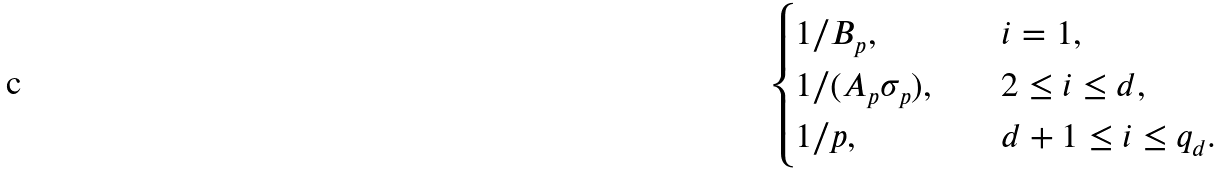<formula> <loc_0><loc_0><loc_500><loc_500>\begin{cases} 1 / B _ { p } , & i = 1 , \\ 1 / ( A _ { p } \sigma _ { p } ) , \quad & 2 \leq i \leq d , \\ 1 / p , & d + 1 \leq i \leq q _ { d } . \end{cases}</formula> 